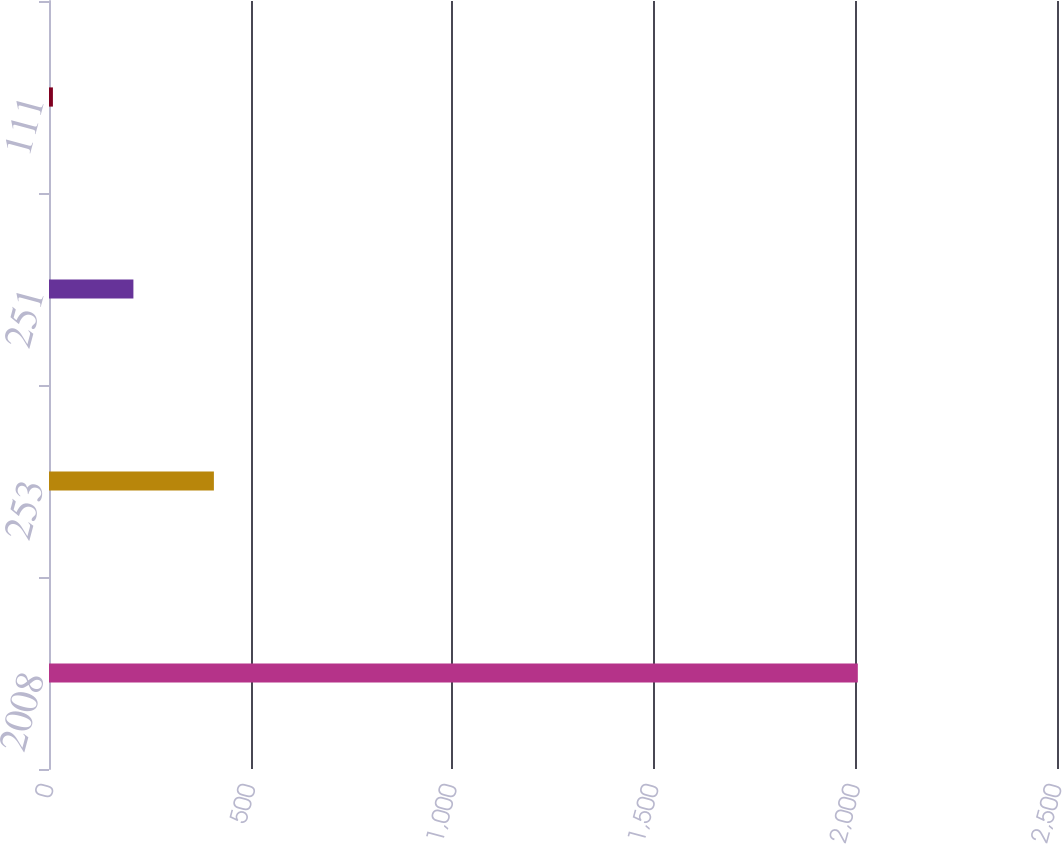Convert chart. <chart><loc_0><loc_0><loc_500><loc_500><bar_chart><fcel>2008<fcel>253<fcel>251<fcel>111<nl><fcel>2006<fcel>408.96<fcel>209.33<fcel>9.7<nl></chart> 